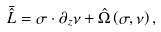Convert formula to latex. <formula><loc_0><loc_0><loc_500><loc_500>\bar { \hat { L } } = \sigma \cdot { \partial } _ { z } \nu + \hat { \Omega } \left ( \sigma , \nu \right ) ,</formula> 